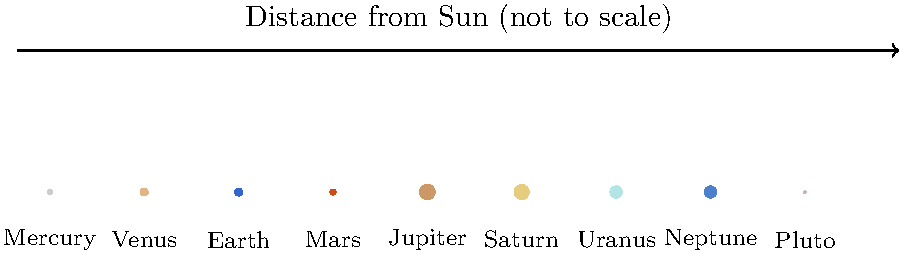As a supportive high school teacher organizing an astronomy-themed community event, you want to create an engaging question about the Solar System. Using the diagram above, which shows the relative sizes of planets (not to scale) and their order from the Sun, what interesting fact can you share about the relationship between Jupiter's size and the inner planets (Mercury, Venus, Earth, and Mars)? To answer this question, let's follow these steps:

1. Identify the inner planets: Mercury, Venus, Earth, and Mars are the first four planets from the Sun.

2. Locate Jupiter: Jupiter is the fifth planet and the largest one in the diagram.

3. Compare sizes:
   - Mercury's diameter: 4,879 km
   - Venus' diameter: 12,104 km
   - Earth's diameter: 12,742 km
   - Mars' diameter: 6,779 km
   - Jupiter's diameter: 139,820 km

4. Calculate the sum of the diameters of the inner planets:
   $4,879 + 12,104 + 12,742 + 6,779 = 36,504$ km

5. Compare Jupiter's diameter to the sum:
   $139,820 \div 36,504 \approx 3.83$

6. Interpret the result: Jupiter's diameter is about 3.83 times larger than the combined diameters of all four inner planets.

This fact highlights the enormous size of Jupiter compared to the inner planets, emphasizing its status as a gas giant and the largest planet in our Solar System.
Answer: Jupiter's diameter is larger than the combined diameters of all four inner planets. 